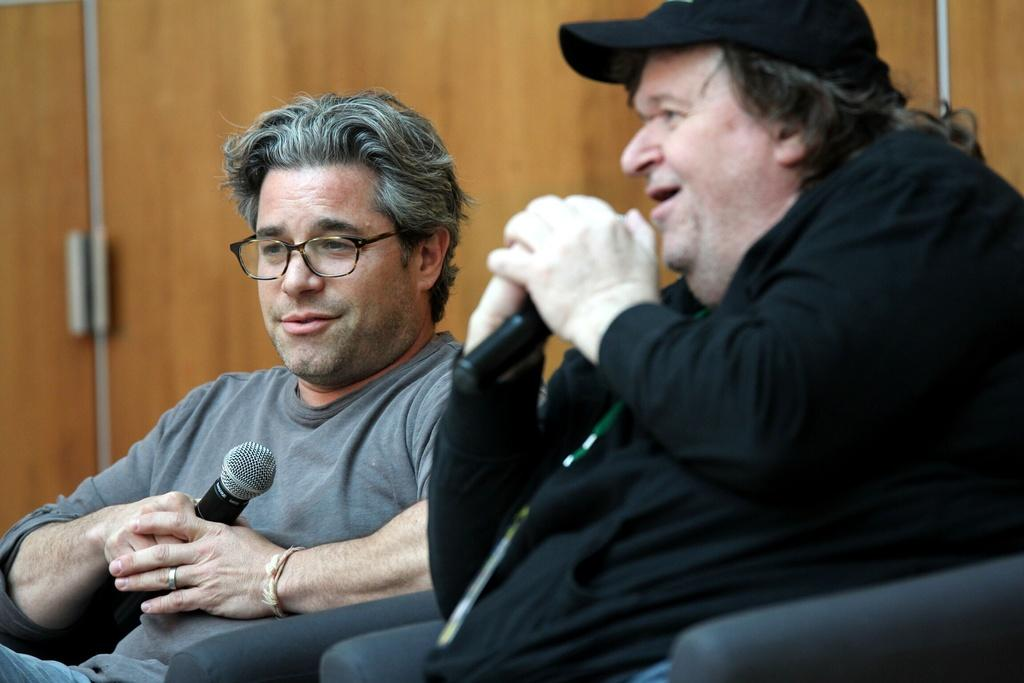How many people are in the image? There are two people in the image. What are the people doing in the image? The people are sitting on chairs and holding microphones. Is one of the people talking in the image? Yes, one of the people is talking in the image. What can be seen in the background of the image? There is a wall visible in the background. How many girls are present in the image? The provided facts do not mention any girls in the image, so we cannot determine the number of girls present. 